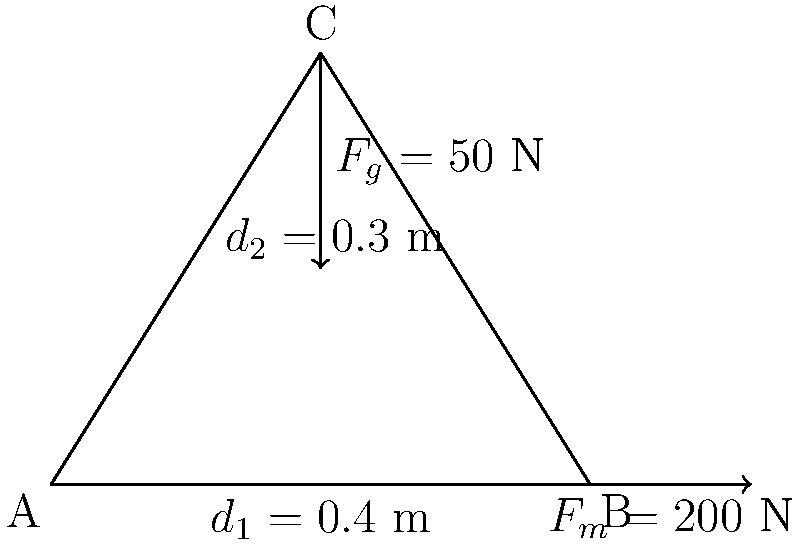Given the free-body diagram of a limb segment, calculate the joint torque at point A. The gravitational force ($F_g$) acting at point C is 50 N, and the muscle force ($F_m$) acting at point B is 200 N. The distances $d_1$ and $d_2$ are 0.4 m and 0.3 m, respectively. To calculate the joint torque at point A, we need to consider the moments created by both forces about this point. Let's follow these steps:

1) The torque equation is: $\tau = r \times F$, where $r$ is the perpendicular distance from the axis of rotation to the line of action of the force.

2) For $F_g$:
   - The perpendicular distance is the full length of the limb: $0.4 + 0.3 = 0.7$ m
   - Torque due to $F_g$: $\tau_g = 0.7 \times 50 = 35$ Nm (clockwise, negative)

3) For $F_m$:
   - The perpendicular distance is $d_1 = 0.4$ m
   - Torque due to $F_m$: $\tau_m = 0.4 \times 200 = 80$ Nm (counterclockwise, positive)

4) The net torque is the sum of these individual torques:
   $\tau_{net} = \tau_m + \tau_g = 80 + (-35) = 45$ Nm

Therefore, the net joint torque at point A is 45 Nm in the counterclockwise direction.
Answer: 45 Nm counterclockwise 